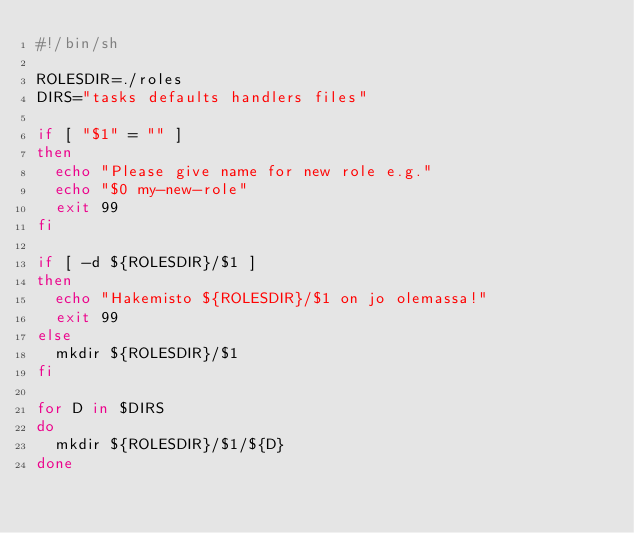Convert code to text. <code><loc_0><loc_0><loc_500><loc_500><_Bash_>#!/bin/sh

ROLESDIR=./roles
DIRS="tasks defaults handlers files"

if [ "$1" = "" ]
then
	echo "Please give name for new role e.g."
	echo "$0 my-new-role"
	exit 99
fi

if [ -d ${ROLESDIR}/$1 ]
then
	echo "Hakemisto ${ROLESDIR}/$1 on jo olemassa!"
	exit 99
else
	mkdir ${ROLESDIR}/$1
fi

for D in $DIRS
do
	mkdir ${ROLESDIR}/$1/${D}
done


</code> 